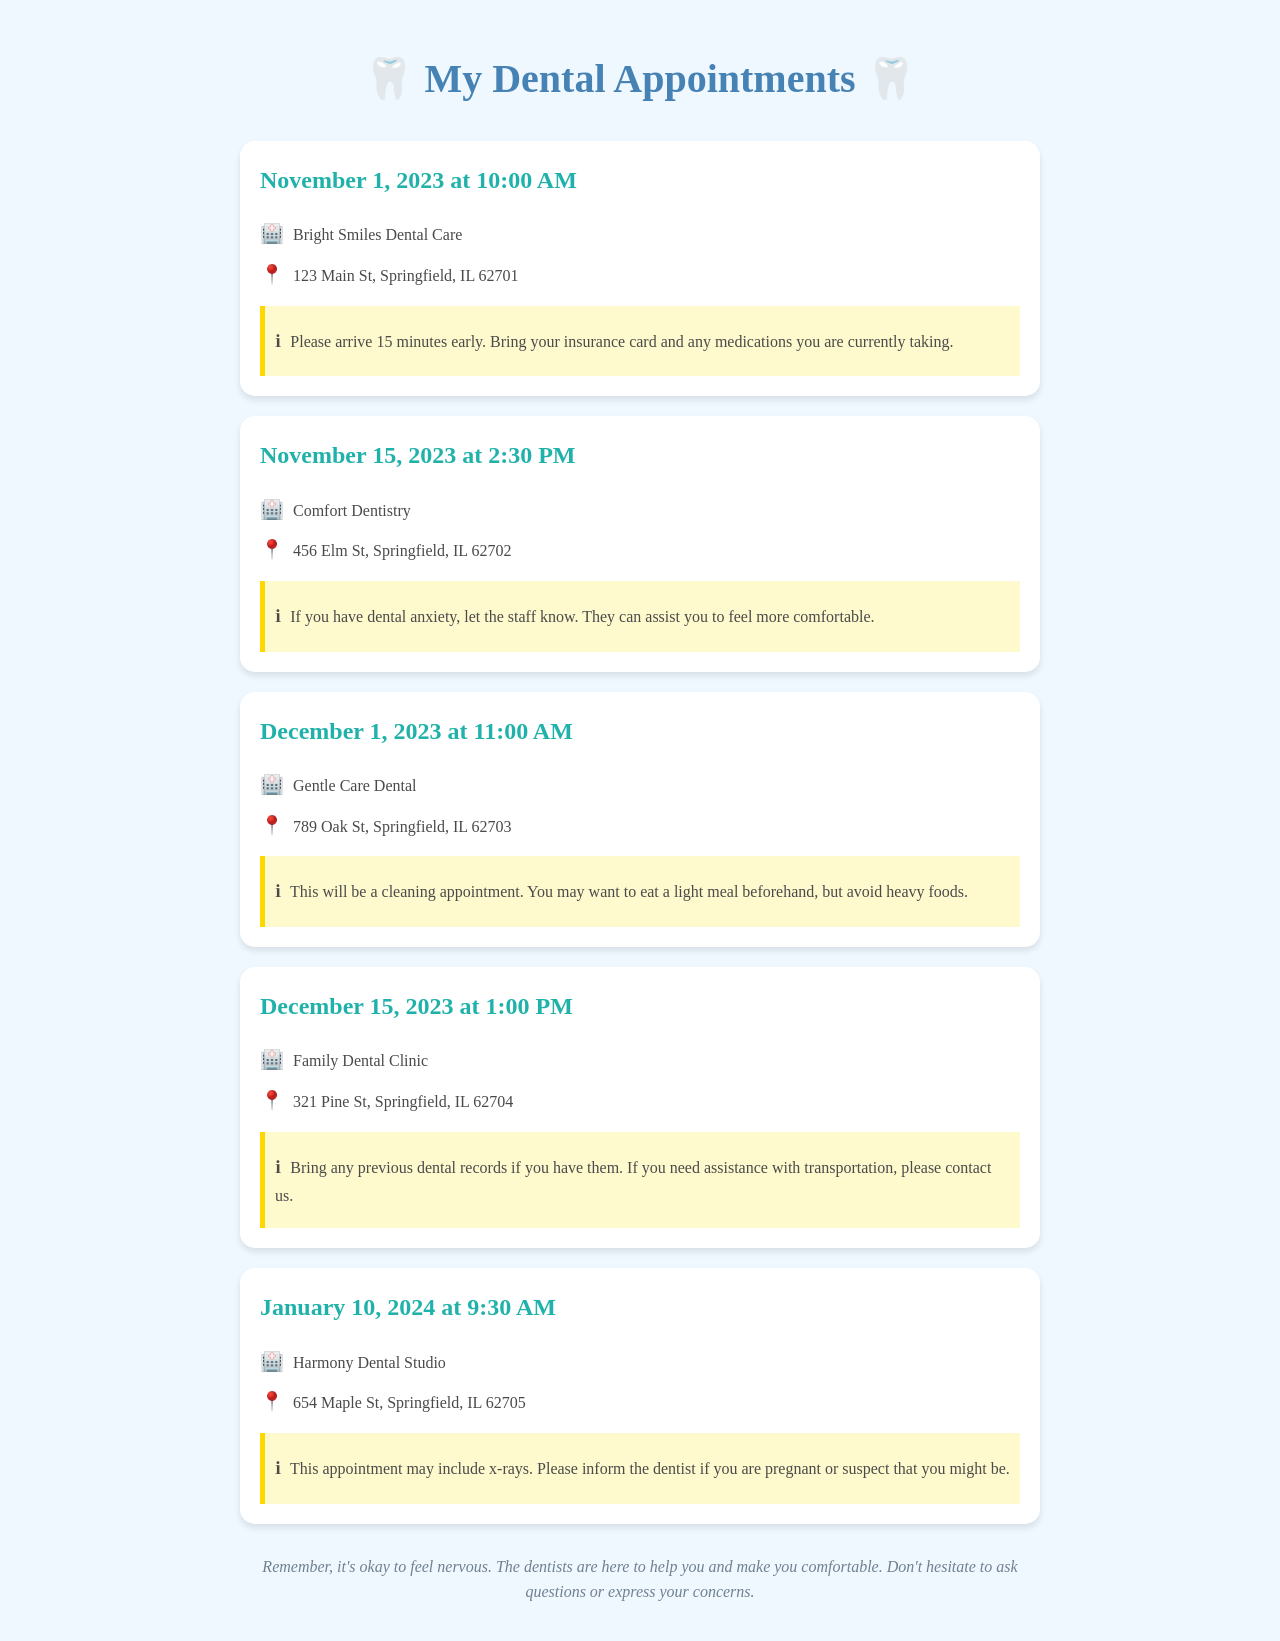What is the first appointment date? The first appointment is scheduled for November 1, 2023.
Answer: November 1, 2023 What time is the appointment on December 15, 2023? The appointment on December 15, 2023, is at 1:00 PM.
Answer: 1:00 PM Where is Comfort Dentistry located? Comfort Dentistry is located at 456 Elm St, Springfield, IL 62702.
Answer: 456 Elm St, Springfield, IL 62702 What should you bring to the November 1 appointment? You should bring your insurance card and any medications you are currently taking.
Answer: Insurance card and medications How many appointments are scheduled in December 2023? There are two appointments scheduled in December 2023.
Answer: Two If you have dental anxiety, which appointment should you mention this at? You should mention this at the appointment on November 15, 2023, at Comfort Dentistry.
Answer: November 15, 2023 What type of appointment is scheduled for December 1, 2023? The appointment on December 1, 2023, is a cleaning appointment.
Answer: Cleaning appointment What is the location for the appointment on January 10, 2024? The appointment on January 10, 2024, is at Harmony Dental Studio, 654 Maple St, Springfield, IL 62705.
Answer: Harmony Dental Studio, 654 Maple St, Springfield, IL 62705 What should you inform the dentist about if you are pregnant? You should inform the dentist that you are pregnant or might be pregnant if x-rays are to be included.
Answer: Pregnant or might be pregnant 